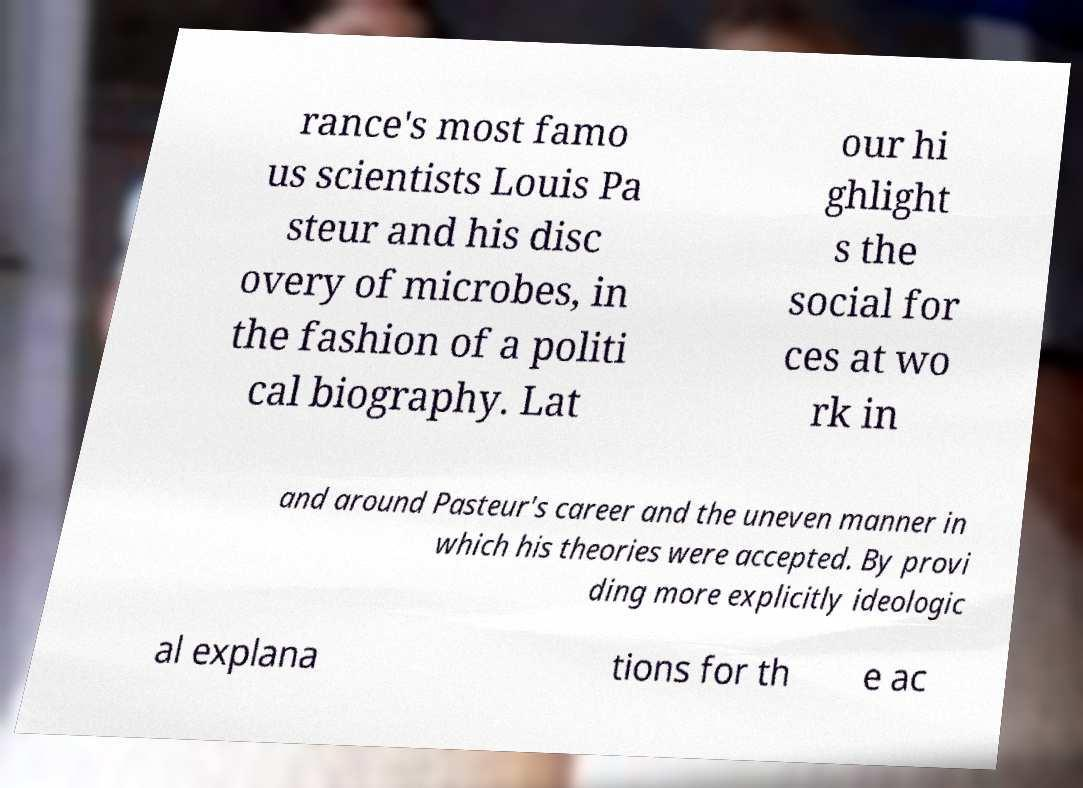For documentation purposes, I need the text within this image transcribed. Could you provide that? rance's most famo us scientists Louis Pa steur and his disc overy of microbes, in the fashion of a politi cal biography. Lat our hi ghlight s the social for ces at wo rk in and around Pasteur's career and the uneven manner in which his theories were accepted. By provi ding more explicitly ideologic al explana tions for th e ac 